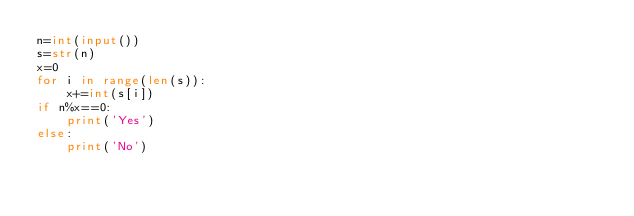<code> <loc_0><loc_0><loc_500><loc_500><_Python_>n=int(input())
s=str(n)
x=0
for i in range(len(s)):
    x+=int(s[i])
if n%x==0:
    print('Yes')
else:
    print('No')</code> 